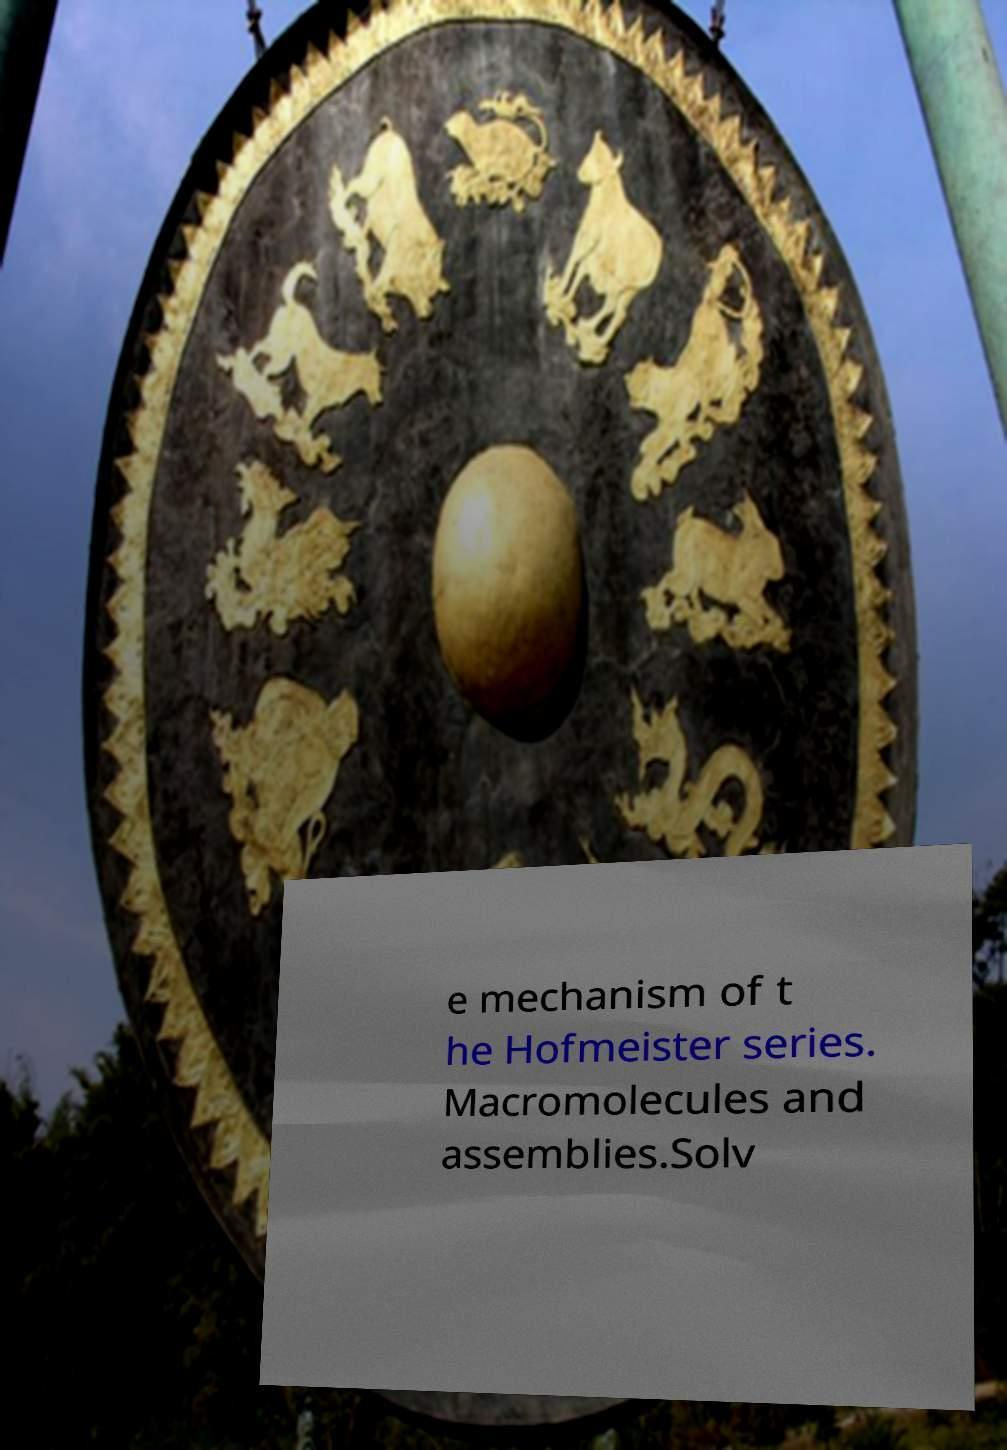Please read and relay the text visible in this image. What does it say? e mechanism of t he Hofmeister series. Macromolecules and assemblies.Solv 